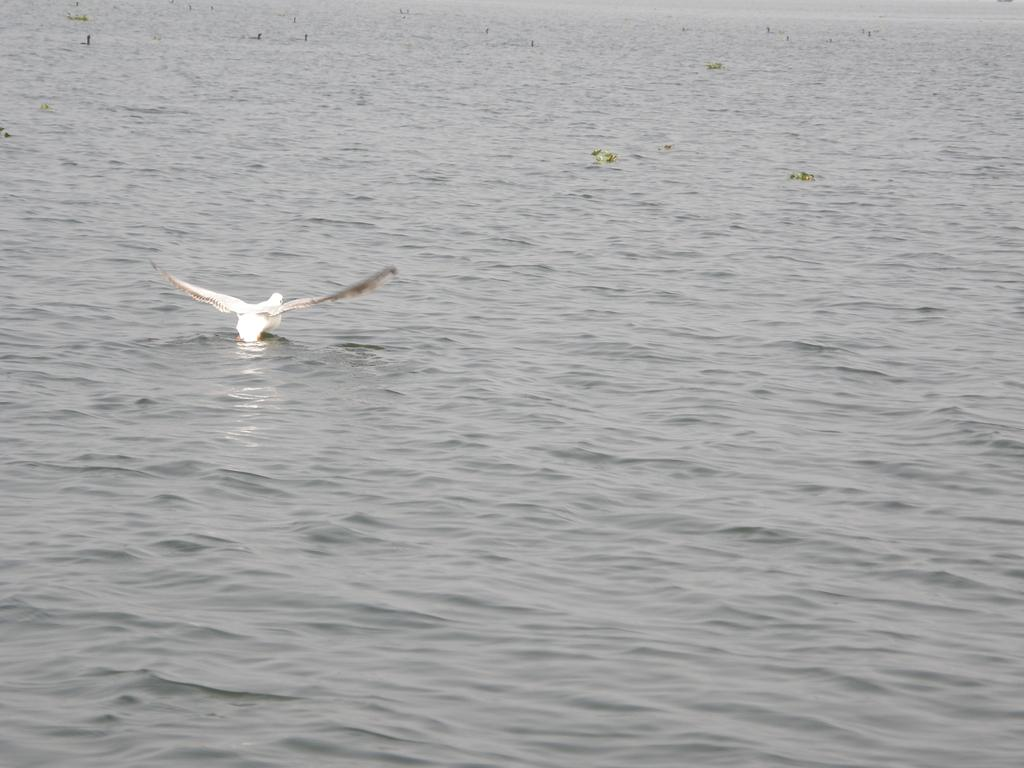What type of animal is in the image? There is a bird in the image. Where is the bird located? The bird is on the water. How would you describe the color of the water? The water is in an ash color. What is the color of the bird? The bird is in a white color. What type of note is the bird holding in the image? There is no note present in the image, and the bird is not holding anything. 